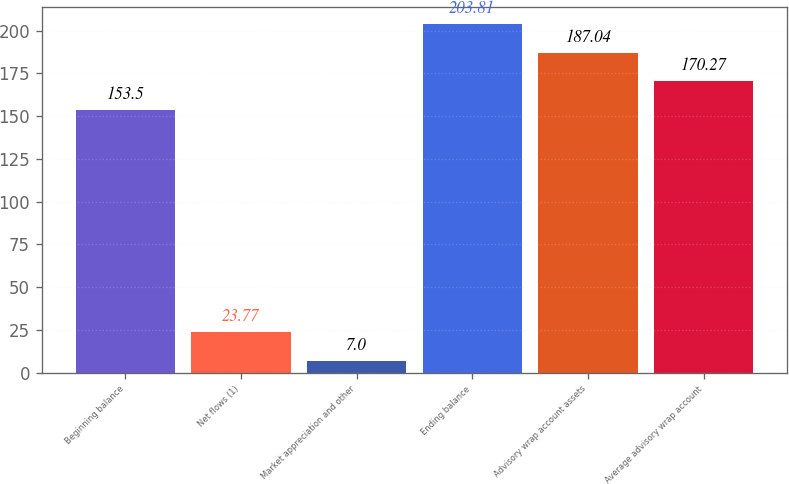Convert chart to OTSL. <chart><loc_0><loc_0><loc_500><loc_500><bar_chart><fcel>Beginning balance<fcel>Net flows (1)<fcel>Market appreciation and other<fcel>Ending balance<fcel>Advisory wrap account assets<fcel>Average advisory wrap account<nl><fcel>153.5<fcel>23.77<fcel>7<fcel>203.81<fcel>187.04<fcel>170.27<nl></chart> 